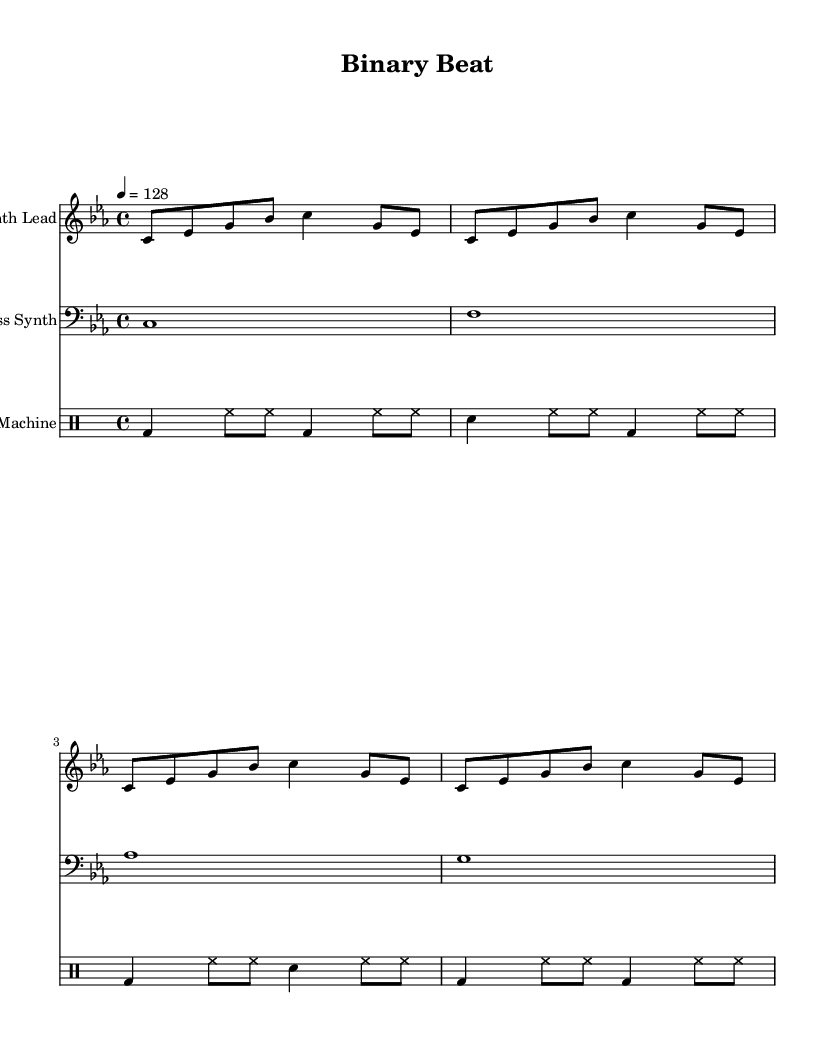What is the key signature of this music? The key signature is C minor, indicated by three flats.
Answer: C minor What is the time signature of this piece? The time signature is 4/4, which is shown at the beginning of the score.
Answer: 4/4 What is the tempo marking for this track? The tempo marking indicates a speed of 128 beats per minute, shown as "4 = 128".
Answer: 128 How many measures are in the synth lead section? The synth lead has four measures, as there are four groups of notes between the bar lines.
Answer: 4 What rhythmic figure is used for the bass synth? The bass synth uses whole notes, which each take up the entire measure.
Answer: Whole notes How many distinct sounds are represented in the drum pattern? The drum pattern includes three distinct sounds: bass drum, snare drum, and hi-hat.
Answer: Three What role does the drum machine play in this music piece? The drum machine provides the rhythmic foundation, creating a consistent driving beat throughout the track.
Answer: Rhythmic foundation 